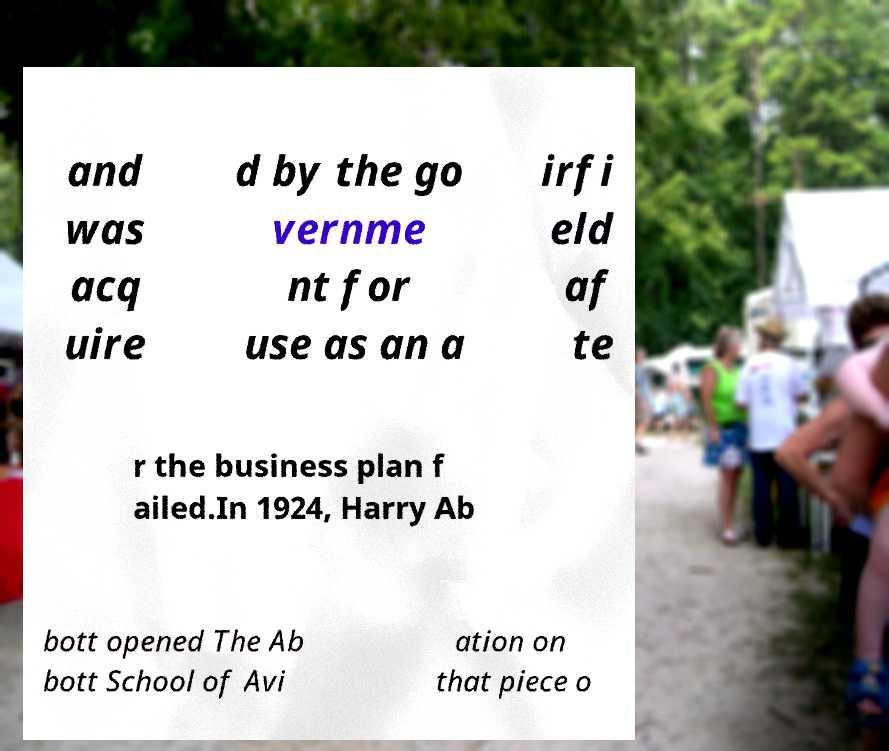Could you assist in decoding the text presented in this image and type it out clearly? and was acq uire d by the go vernme nt for use as an a irfi eld af te r the business plan f ailed.In 1924, Harry Ab bott opened The Ab bott School of Avi ation on that piece o 